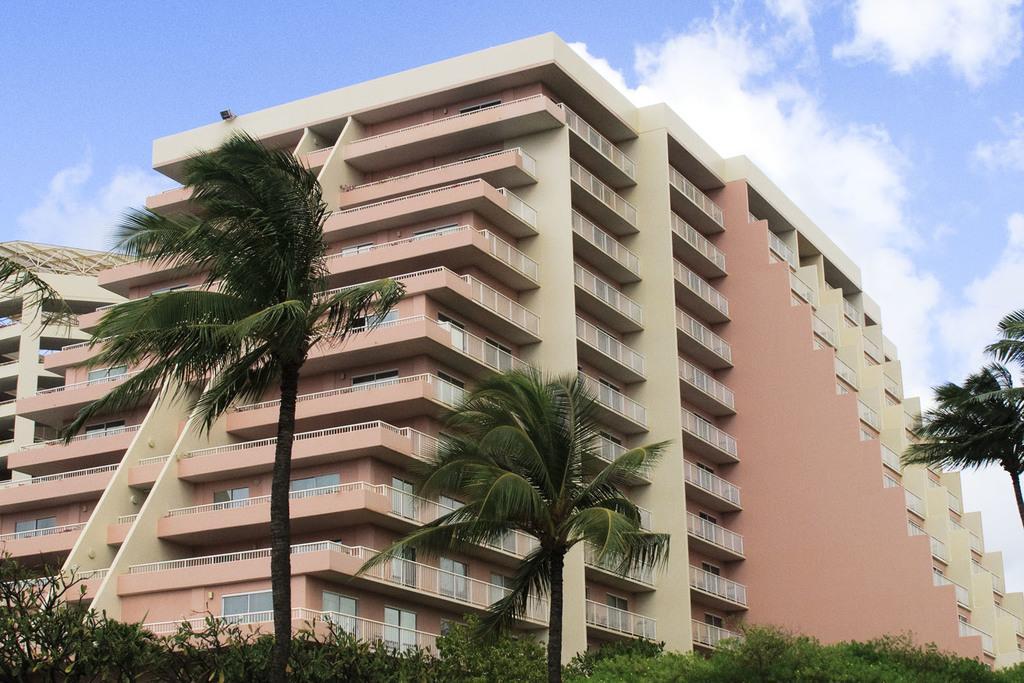In one or two sentences, can you explain what this image depicts? This picture contains the building which is in white and pink color. We even see windows and iron railing. At the bottom of the picture, we see plants and trees and at the top of the picture, we see the sky, which is blue in color. 